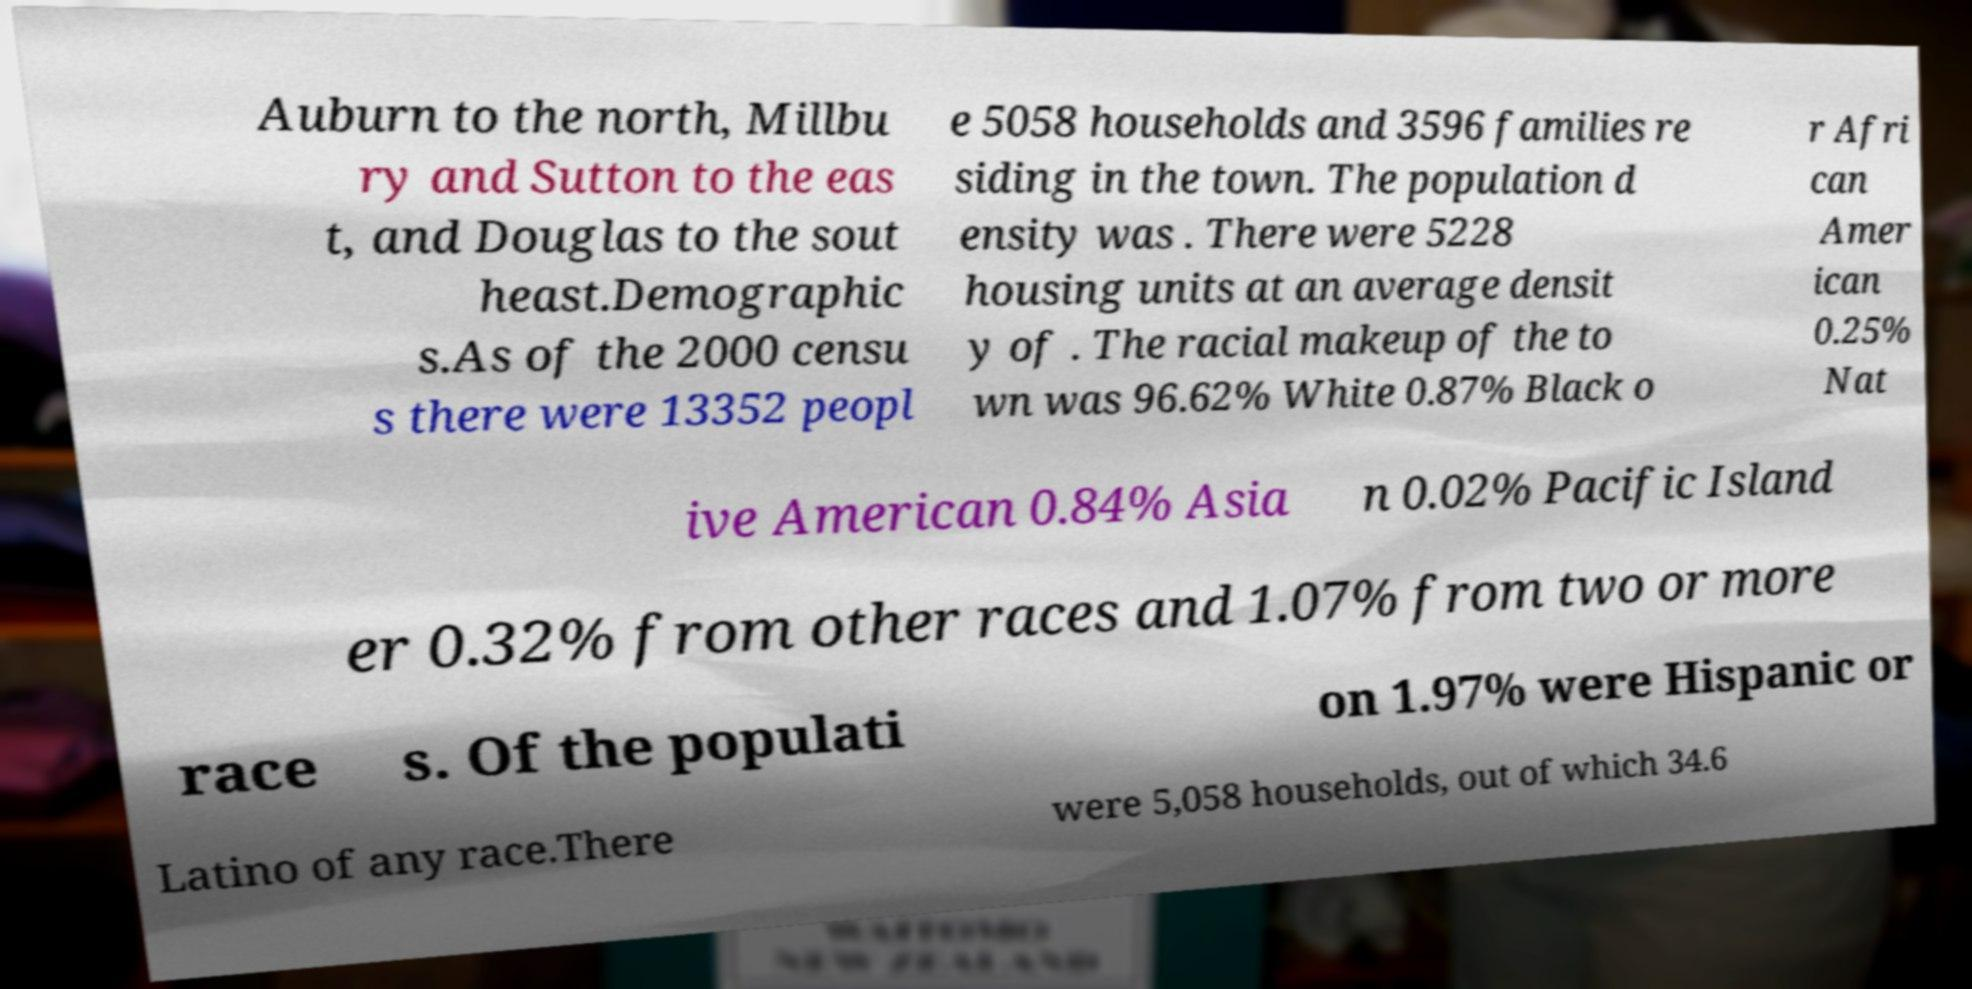There's text embedded in this image that I need extracted. Can you transcribe it verbatim? Auburn to the north, Millbu ry and Sutton to the eas t, and Douglas to the sout heast.Demographic s.As of the 2000 censu s there were 13352 peopl e 5058 households and 3596 families re siding in the town. The population d ensity was . There were 5228 housing units at an average densit y of . The racial makeup of the to wn was 96.62% White 0.87% Black o r Afri can Amer ican 0.25% Nat ive American 0.84% Asia n 0.02% Pacific Island er 0.32% from other races and 1.07% from two or more race s. Of the populati on 1.97% were Hispanic or Latino of any race.There were 5,058 households, out of which 34.6 